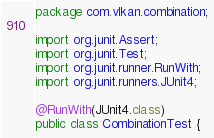<code> <loc_0><loc_0><loc_500><loc_500><_Java_>package com.vlkan.combination;

import org.junit.Assert;
import org.junit.Test;
import org.junit.runner.RunWith;
import org.junit.runners.JUnit4;

@RunWith(JUnit4.class)
public class CombinationTest {
</code> 